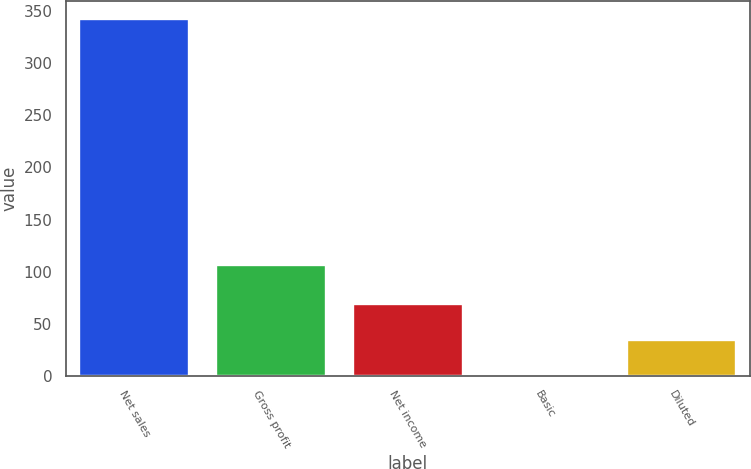<chart> <loc_0><loc_0><loc_500><loc_500><bar_chart><fcel>Net sales<fcel>Gross profit<fcel>Net income<fcel>Basic<fcel>Diluted<nl><fcel>342.7<fcel>106.6<fcel>68.81<fcel>0.33<fcel>34.57<nl></chart> 